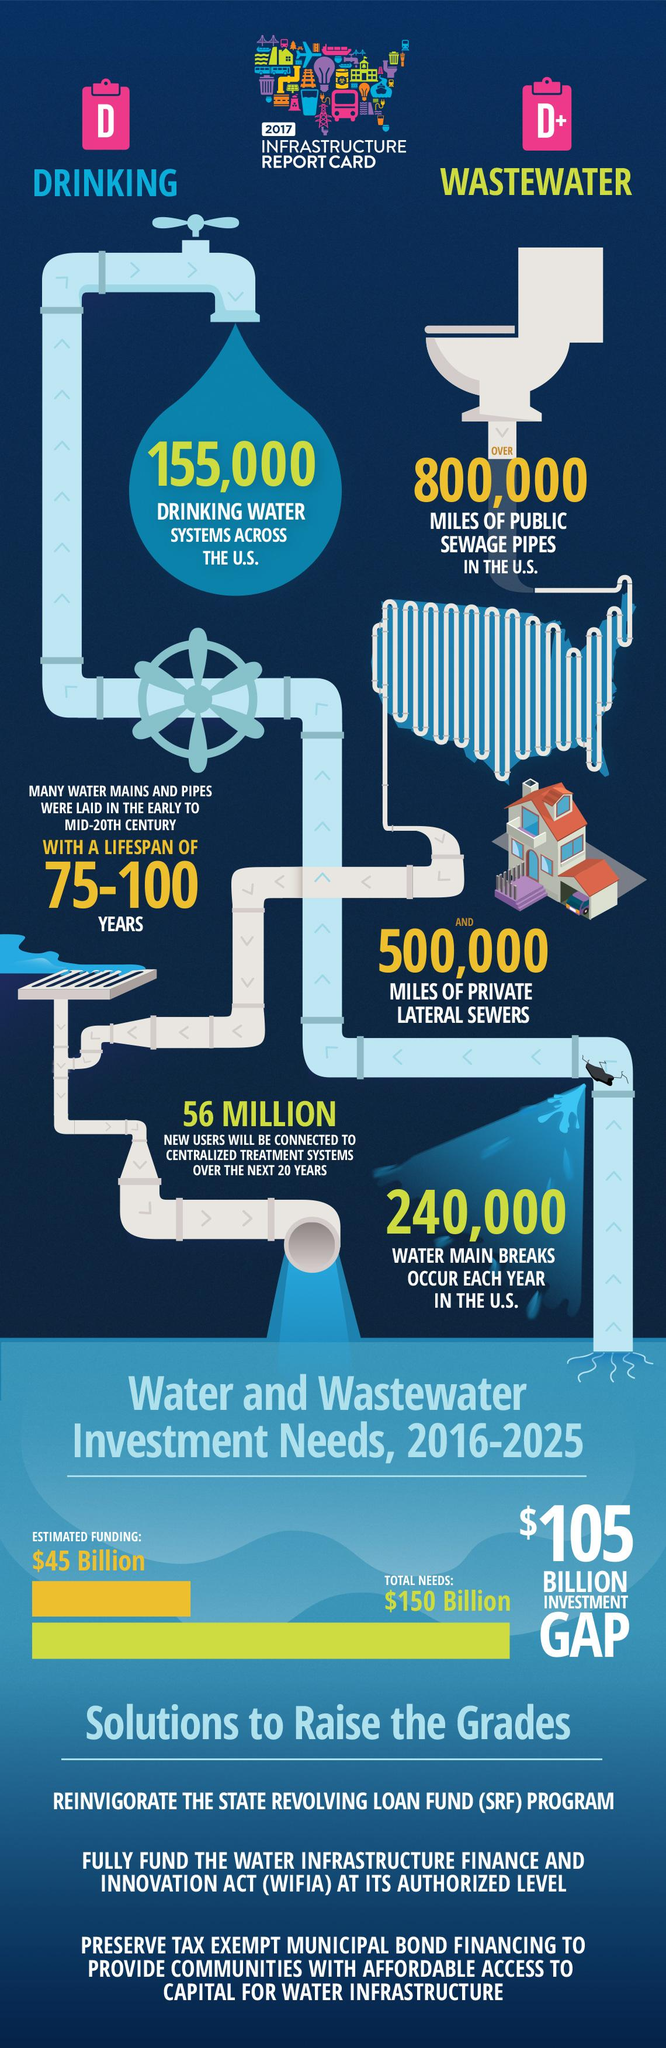Outline some significant characteristics in this image. In 2017, there were approximately 155,000 drinking water systems across the United States. 